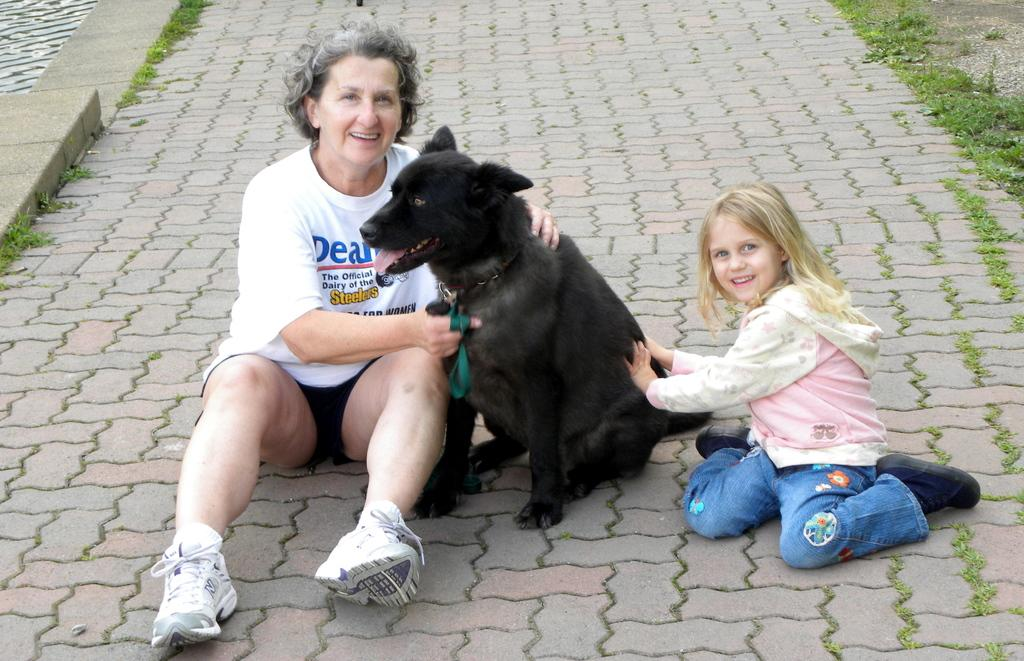Who is present in the image? There is a woman and a girl in the image. What are the woman and the girl doing in the image? They are seated and holding a dog. Where is the dog positioned between the woman and the girl? The dog is in the middle of the woman and the girl. What is the setting of the image? The scene takes place on a sidewalk. What emotion is the woman expressing towards the girl in the image? The image does not provide any information about the emotions of the woman or the girl. 